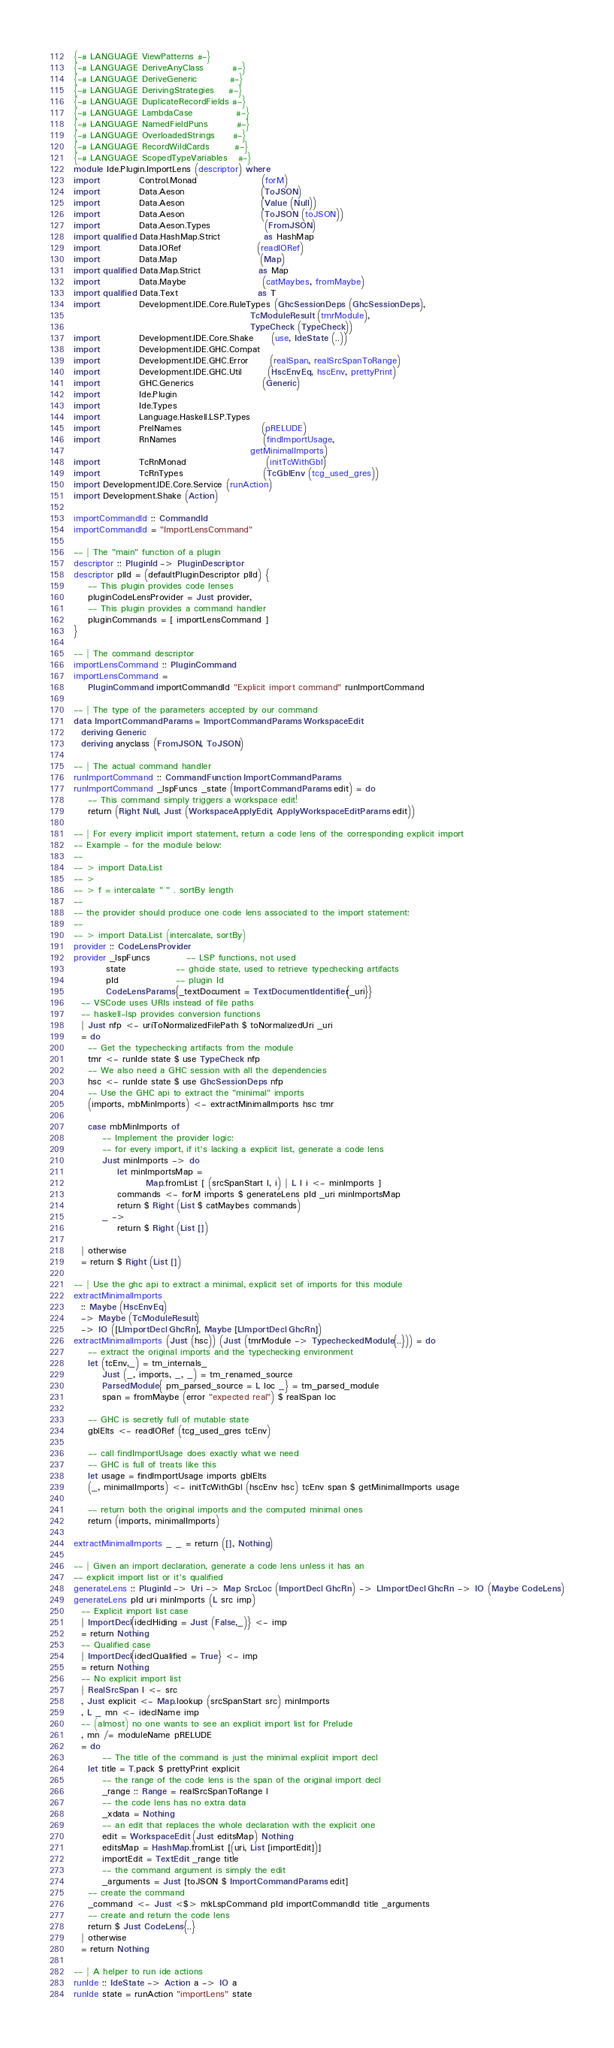Convert code to text. <code><loc_0><loc_0><loc_500><loc_500><_Haskell_>{-# LANGUAGE ViewPatterns #-}
{-# LANGUAGE DeriveAnyClass        #-}
{-# LANGUAGE DeriveGeneric         #-}
{-# LANGUAGE DerivingStrategies    #-}
{-# LANGUAGE DuplicateRecordFields #-}
{-# LANGUAGE LambdaCase            #-}
{-# LANGUAGE NamedFieldPuns        #-}
{-# LANGUAGE OverloadedStrings     #-}
{-# LANGUAGE RecordWildCards       #-}
{-# LANGUAGE ScopedTypeVariables   #-}
module Ide.Plugin.ImportLens (descriptor) where
import           Control.Monad                  (forM)
import           Data.Aeson                     (ToJSON)
import           Data.Aeson                     (Value (Null))
import           Data.Aeson                     (ToJSON (toJSON))
import           Data.Aeson.Types               (FromJSON)
import qualified Data.HashMap.Strict            as HashMap
import           Data.IORef                     (readIORef)
import           Data.Map                       (Map)
import qualified Data.Map.Strict                as Map
import           Data.Maybe                     (catMaybes, fromMaybe)
import qualified Data.Text                      as T
import           Development.IDE.Core.RuleTypes (GhcSessionDeps (GhcSessionDeps),
                                                 TcModuleResult (tmrModule),
                                                 TypeCheck (TypeCheck))
import           Development.IDE.Core.Shake     (use, IdeState (..))
import           Development.IDE.GHC.Compat
import           Development.IDE.GHC.Error      (realSpan, realSrcSpanToRange)
import           Development.IDE.GHC.Util       (HscEnvEq, hscEnv, prettyPrint)
import           GHC.Generics                   (Generic)
import           Ide.Plugin
import           Ide.Types
import           Language.Haskell.LSP.Types
import           PrelNames                      (pRELUDE)
import           RnNames                        (findImportUsage,
                                                 getMinimalImports)
import           TcRnMonad                      (initTcWithGbl)
import           TcRnTypes                      (TcGblEnv (tcg_used_gres))
import Development.IDE.Core.Service (runAction)
import Development.Shake (Action)

importCommandId :: CommandId
importCommandId = "ImportLensCommand"

-- | The "main" function of a plugin
descriptor :: PluginId -> PluginDescriptor
descriptor plId = (defaultPluginDescriptor plId) {
    -- This plugin provides code lenses
    pluginCodeLensProvider = Just provider,
    -- This plugin provides a command handler
    pluginCommands = [ importLensCommand ]
}

-- | The command descriptor
importLensCommand :: PluginCommand
importLensCommand =
    PluginCommand importCommandId "Explicit import command" runImportCommand

-- | The type of the parameters accepted by our command
data ImportCommandParams = ImportCommandParams WorkspaceEdit
  deriving Generic
  deriving anyclass (FromJSON, ToJSON)

-- | The actual command handler
runImportCommand :: CommandFunction ImportCommandParams
runImportCommand _lspFuncs _state (ImportCommandParams edit) = do
    -- This command simply triggers a workspace edit!
    return (Right Null, Just (WorkspaceApplyEdit, ApplyWorkspaceEditParams edit))

-- | For every implicit import statement, return a code lens of the corresponding explicit import
-- Example - for the module below:
--
-- > import Data.List
-- >
-- > f = intercalate " " . sortBy length
--
-- the provider should produce one code lens associated to the import statement:
--
-- > import Data.List (intercalate, sortBy)
provider :: CodeLensProvider
provider _lspFuncs          -- LSP functions, not used
         state              -- ghcide state, used to retrieve typechecking artifacts
         pId                -- plugin Id
         CodeLensParams{_textDocument = TextDocumentIdentifier{_uri}}
  -- VSCode uses URIs instead of file paths
  -- haskell-lsp provides conversion functions
  | Just nfp <- uriToNormalizedFilePath $ toNormalizedUri _uri
  = do
    -- Get the typechecking artifacts from the module
    tmr <- runIde state $ use TypeCheck nfp
    -- We also need a GHC session with all the dependencies
    hsc <- runIde state $ use GhcSessionDeps nfp
    -- Use the GHC api to extract the "minimal" imports
    (imports, mbMinImports) <- extractMinimalImports hsc tmr

    case mbMinImports of
        -- Implement the provider logic:
        -- for every import, if it's lacking a explicit list, generate a code lens
        Just minImports -> do
            let minImportsMap =
                    Map.fromList [ (srcSpanStart l, i) | L l i <- minImports ]
            commands <- forM imports $ generateLens pId _uri minImportsMap
            return $ Right (List $ catMaybes commands)
        _ ->
            return $ Right (List [])

  | otherwise
  = return $ Right (List [])

-- | Use the ghc api to extract a minimal, explicit set of imports for this module
extractMinimalImports
  :: Maybe (HscEnvEq)
  -> Maybe (TcModuleResult)
  -> IO ([LImportDecl GhcRn], Maybe [LImportDecl GhcRn])
extractMinimalImports (Just (hsc)) (Just (tmrModule -> TypecheckedModule{..})) = do
    -- extract the original imports and the typechecking environment
    let (tcEnv,_) = tm_internals_
        Just (_, imports, _, _) = tm_renamed_source
        ParsedModule{ pm_parsed_source = L loc _} = tm_parsed_module
        span = fromMaybe (error "expected real") $ realSpan loc

    -- GHC is secretly full of mutable state
    gblElts <- readIORef (tcg_used_gres tcEnv)

    -- call findImportUsage does exactly what we need
    -- GHC is full of treats like this
    let usage = findImportUsage imports gblElts
    (_, minimalImports) <- initTcWithGbl (hscEnv hsc) tcEnv span $ getMinimalImports usage

    -- return both the original imports and the computed minimal ones
    return (imports, minimalImports)

extractMinimalImports _ _ = return ([], Nothing)

-- | Given an import declaration, generate a code lens unless it has an
-- explicit import list or it's qualified
generateLens :: PluginId -> Uri -> Map SrcLoc (ImportDecl GhcRn) -> LImportDecl GhcRn -> IO (Maybe CodeLens)
generateLens pId uri minImports (L src imp)
  -- Explicit import list case
  | ImportDecl{ideclHiding = Just (False,_)} <- imp
  = return Nothing
  -- Qualified case
  | ImportDecl{ideclQualified = True} <- imp
  = return Nothing
  -- No explicit import list
  | RealSrcSpan l <- src
  , Just explicit <- Map.lookup (srcSpanStart src) minImports
  , L _ mn <- ideclName imp
  -- (almost) no one wants to see an explicit import list for Prelude
  , mn /= moduleName pRELUDE
  = do
        -- The title of the command is just the minimal explicit import decl
    let title = T.pack $ prettyPrint explicit
        -- the range of the code lens is the span of the original import decl
        _range :: Range = realSrcSpanToRange l
        -- the code lens has no extra data
        _xdata = Nothing
        -- an edit that replaces the whole declaration with the explicit one
        edit = WorkspaceEdit (Just editsMap) Nothing
        editsMap = HashMap.fromList [(uri, List [importEdit])]
        importEdit = TextEdit _range title
        -- the command argument is simply the edit
        _arguments = Just [toJSON $ ImportCommandParams edit]
    -- create the command
    _command <- Just <$> mkLspCommand pId importCommandId title _arguments
    -- create and return the code lens
    return $ Just CodeLens{..}
  | otherwise
  = return Nothing

-- | A helper to run ide actions
runIde :: IdeState -> Action a -> IO a
runIde state = runAction "importLens" state
</code> 